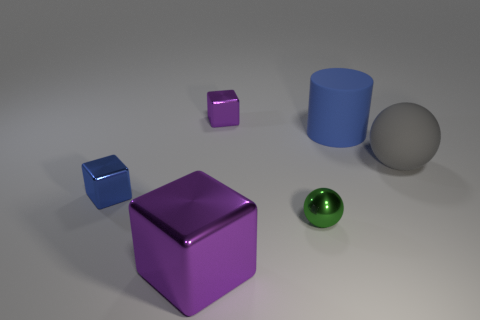Are there the same number of tiny purple metal things on the right side of the tiny purple thing and cylinders?
Keep it short and to the point. No. How many things are to the left of the blue cylinder and in front of the tiny purple cube?
Give a very brief answer. 3. Is the shape of the purple metallic thing that is in front of the blue rubber cylinder the same as  the green shiny object?
Your response must be concise. No. There is a cylinder that is the same size as the matte sphere; what is it made of?
Keep it short and to the point. Rubber. Is the number of tiny purple metal things that are to the right of the tiny purple metallic block the same as the number of blue rubber things right of the rubber sphere?
Provide a short and direct response. Yes. There is a cube that is right of the purple object that is left of the small purple shiny block; what number of purple metallic objects are to the right of it?
Offer a very short reply. 0. Does the large rubber sphere have the same color as the small shiny block that is left of the big purple block?
Your answer should be compact. No. What is the size of the gray sphere that is the same material as the blue cylinder?
Your answer should be very brief. Large. Is the number of large gray matte spheres that are in front of the small green sphere greater than the number of small cyan matte blocks?
Your answer should be compact. No. What is the material of the big thing in front of the small metallic thing that is to the right of the small cube that is on the right side of the large shiny thing?
Keep it short and to the point. Metal. 